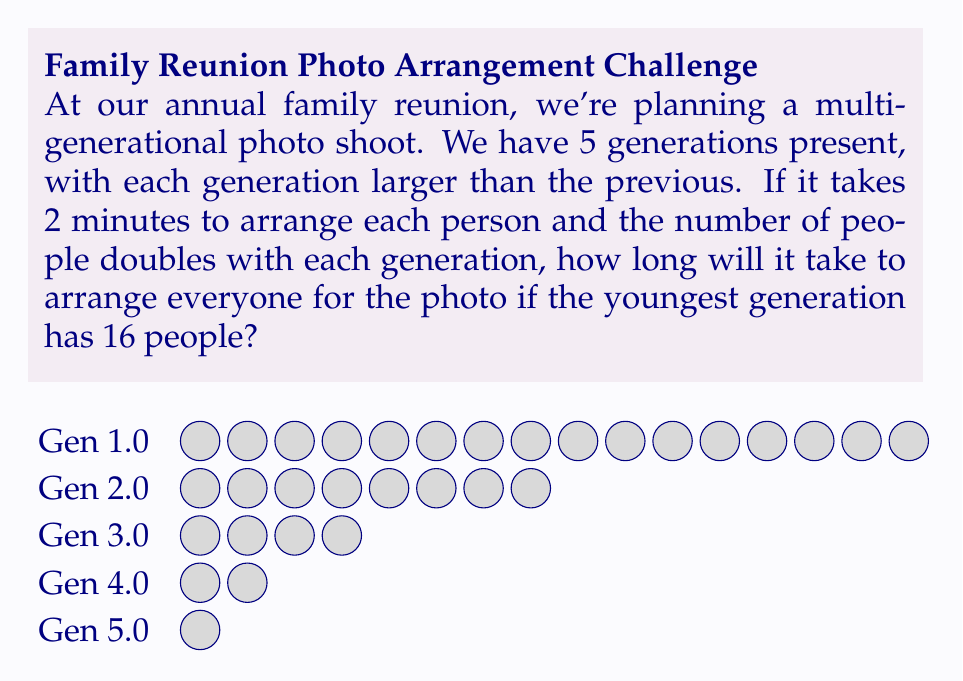What is the answer to this math problem? Let's approach this step-by-step:

1) First, we need to calculate the number of people in each generation:
   Gen 5 (youngest): 16 people
   Gen 4: 16 ÷ 2 = 8 people
   Gen 3: 8 ÷ 2 = 4 people
   Gen 2: 4 ÷ 2 = 2 people
   Gen 1 (oldest): 2 ÷ 2 = 1 person

2) Now, let's calculate the total number of people:
   $$ \text{Total} = 16 + 8 + 4 + 2 + 1 = 31 \text{ people} $$

3) We're told it takes 2 minutes to arrange each person. So we can calculate the total time:
   $$ \text{Time} = 31 \text{ people} \times 2 \text{ minutes/person} = 62 \text{ minutes} $$

4) To convert this to hours and minutes:
   $$ 62 \text{ minutes} = 1 \text{ hour and } 2 \text{ minutes} $$

Therefore, it will take 1 hour and 2 minutes to arrange everyone for the photo.
Answer: 1 hour and 2 minutes 